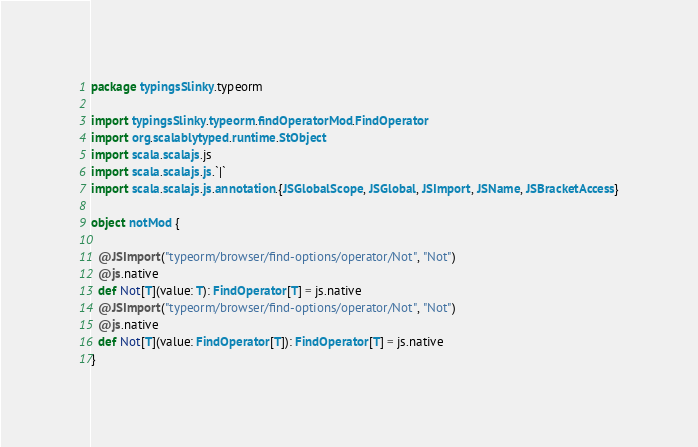Convert code to text. <code><loc_0><loc_0><loc_500><loc_500><_Scala_>package typingsSlinky.typeorm

import typingsSlinky.typeorm.findOperatorMod.FindOperator
import org.scalablytyped.runtime.StObject
import scala.scalajs.js
import scala.scalajs.js.`|`
import scala.scalajs.js.annotation.{JSGlobalScope, JSGlobal, JSImport, JSName, JSBracketAccess}

object notMod {
  
  @JSImport("typeorm/browser/find-options/operator/Not", "Not")
  @js.native
  def Not[T](value: T): FindOperator[T] = js.native
  @JSImport("typeorm/browser/find-options/operator/Not", "Not")
  @js.native
  def Not[T](value: FindOperator[T]): FindOperator[T] = js.native
}
</code> 